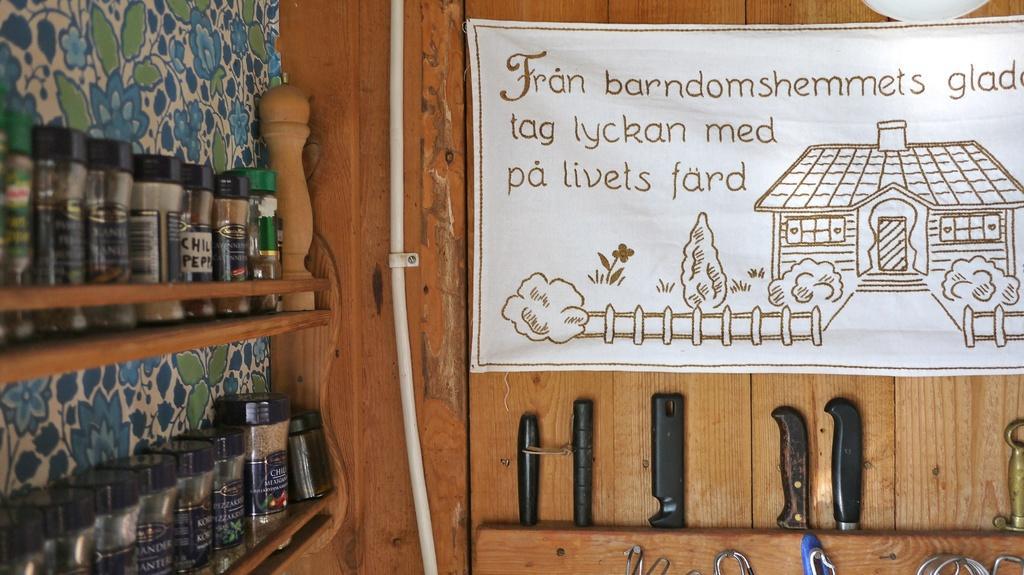Could you give a brief overview of what you see in this image? In the foreground of the image we can see some knives and some objects placed on the wooden surface and a banner with a photo and some text. On the left side of the image we can see group of bottles placed in racks and a cable. 